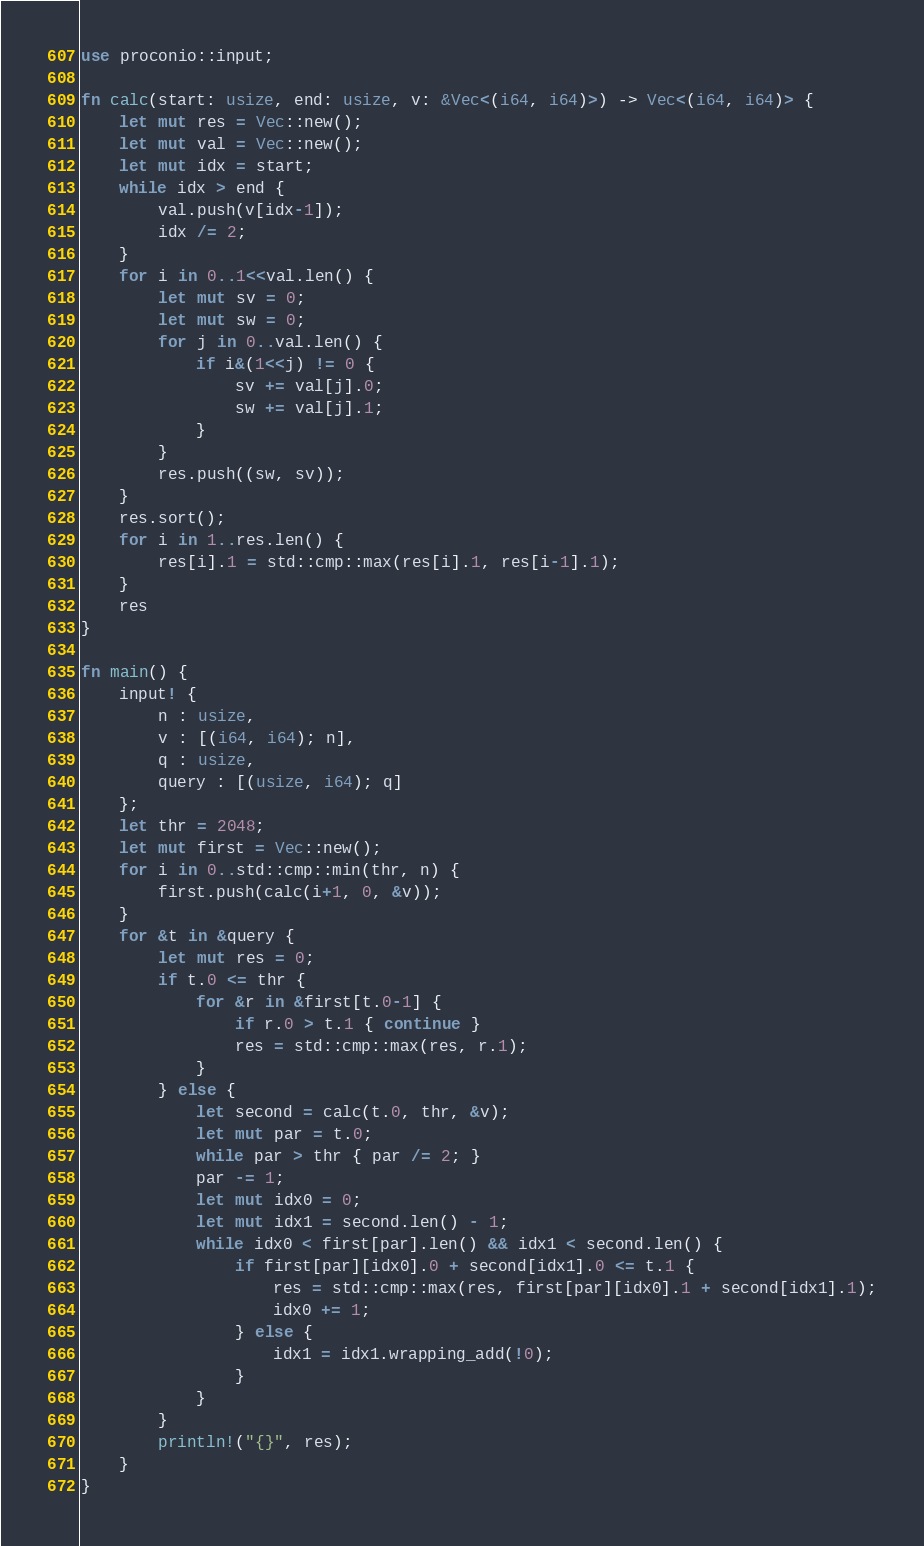Convert code to text. <code><loc_0><loc_0><loc_500><loc_500><_Rust_>use proconio::input;

fn calc(start: usize, end: usize, v: &Vec<(i64, i64)>) -> Vec<(i64, i64)> {
    let mut res = Vec::new();
    let mut val = Vec::new();
    let mut idx = start;
    while idx > end {
        val.push(v[idx-1]);
        idx /= 2;
    }
    for i in 0..1<<val.len() {
        let mut sv = 0;
        let mut sw = 0;
        for j in 0..val.len() {
            if i&(1<<j) != 0 {
                sv += val[j].0;
                sw += val[j].1;
            }
        }
        res.push((sw, sv));
    }
    res.sort();
    for i in 1..res.len() {
        res[i].1 = std::cmp::max(res[i].1, res[i-1].1);
    }
    res
}

fn main() {
    input! {
        n : usize,
        v : [(i64, i64); n],
        q : usize,
        query : [(usize, i64); q]
    };
    let thr = 2048;
    let mut first = Vec::new();
    for i in 0..std::cmp::min(thr, n) {
        first.push(calc(i+1, 0, &v));
    }
    for &t in &query {
        let mut res = 0;
        if t.0 <= thr {
            for &r in &first[t.0-1] {
                if r.0 > t.1 { continue }
                res = std::cmp::max(res, r.1);
            }
        } else {
            let second = calc(t.0, thr, &v);
            let mut par = t.0;
            while par > thr { par /= 2; }
            par -= 1;
            let mut idx0 = 0;
            let mut idx1 = second.len() - 1;
            while idx0 < first[par].len() && idx1 < second.len() {
                if first[par][idx0].0 + second[idx1].0 <= t.1 {
                    res = std::cmp::max(res, first[par][idx0].1 + second[idx1].1);
                    idx0 += 1;
                } else {
                    idx1 = idx1.wrapping_add(!0);
                }
            }
        }
        println!("{}", res);
    }
}
</code> 